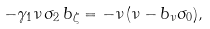<formula> <loc_0><loc_0><loc_500><loc_500>- \gamma _ { 1 } \nu \, \sigma _ { 2 } \, b _ { \zeta } = - \nu \, ( \nu - b _ { \nu } \sigma _ { 0 } ) ,</formula> 